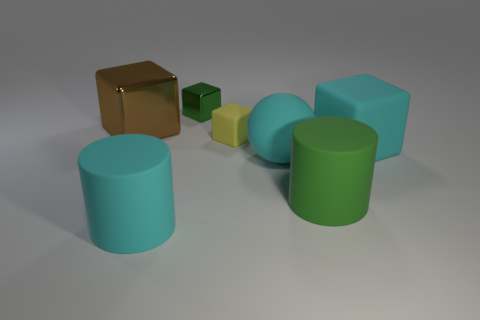Add 1 small metal spheres. How many objects exist? 8 Subtract all brown metal blocks. How many blocks are left? 3 Subtract all balls. How many objects are left? 6 Subtract 1 blocks. How many blocks are left? 3 Add 5 large cyan blocks. How many large cyan blocks exist? 6 Subtract all green cylinders. How many cylinders are left? 1 Subtract 0 blue spheres. How many objects are left? 7 Subtract all yellow cubes. Subtract all blue cylinders. How many cubes are left? 3 Subtract all big brown cubes. Subtract all matte objects. How many objects are left? 1 Add 7 metal blocks. How many metal blocks are left? 9 